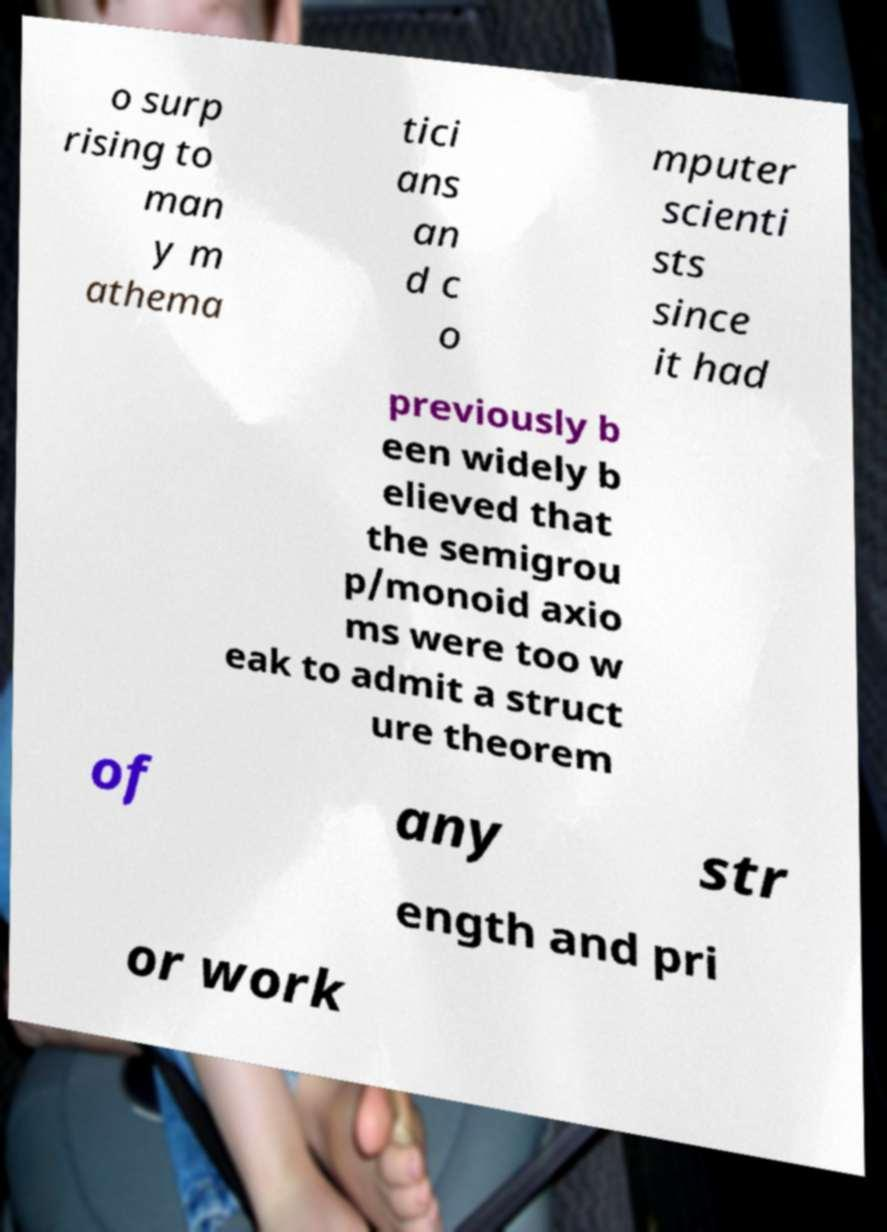What messages or text are displayed in this image? I need them in a readable, typed format. o surp rising to man y m athema tici ans an d c o mputer scienti sts since it had previously b een widely b elieved that the semigrou p/monoid axio ms were too w eak to admit a struct ure theorem of any str ength and pri or work 